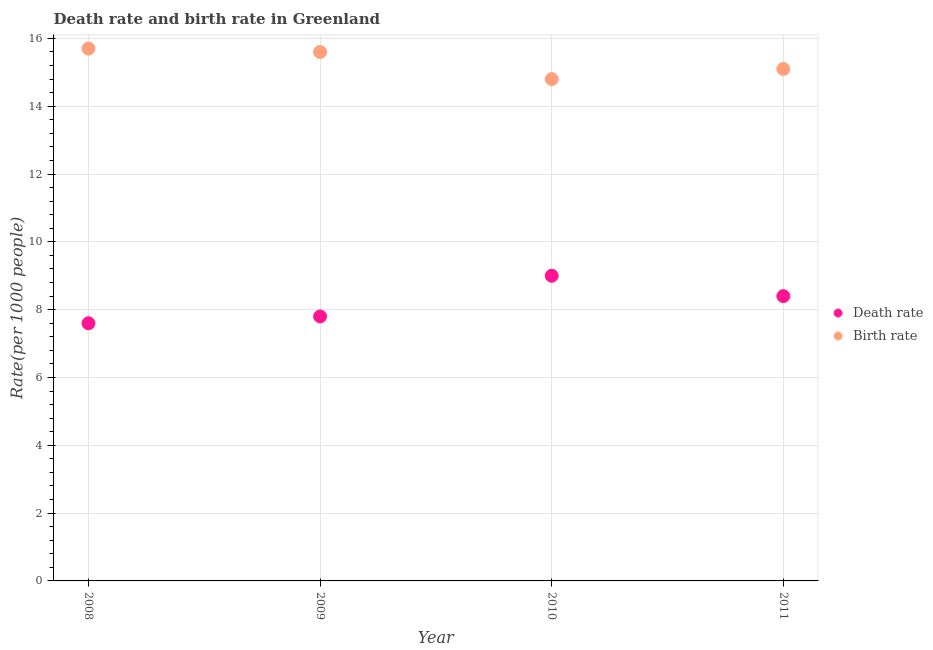How many different coloured dotlines are there?
Your response must be concise. 2. What is the death rate in 2010?
Your answer should be very brief. 9. Across all years, what is the maximum death rate?
Provide a short and direct response. 9. Across all years, what is the minimum birth rate?
Offer a terse response. 14.8. In which year was the death rate minimum?
Offer a terse response. 2008. What is the total death rate in the graph?
Offer a terse response. 32.8. What is the difference between the death rate in 2010 and that in 2011?
Ensure brevity in your answer.  0.6. What is the difference between the birth rate in 2011 and the death rate in 2009?
Provide a short and direct response. 7.3. What is the average birth rate per year?
Keep it short and to the point. 15.3. In the year 2011, what is the difference between the birth rate and death rate?
Provide a short and direct response. 6.7. In how many years, is the birth rate greater than 1.6?
Make the answer very short. 4. What is the ratio of the death rate in 2008 to that in 2009?
Provide a succinct answer. 0.97. Is the difference between the death rate in 2008 and 2009 greater than the difference between the birth rate in 2008 and 2009?
Make the answer very short. No. What is the difference between the highest and the second highest birth rate?
Your answer should be compact. 0.1. What is the difference between the highest and the lowest death rate?
Your answer should be compact. 1.4. In how many years, is the death rate greater than the average death rate taken over all years?
Your answer should be very brief. 2. Does the death rate monotonically increase over the years?
Make the answer very short. No. How many years are there in the graph?
Your answer should be compact. 4. What is the difference between two consecutive major ticks on the Y-axis?
Your answer should be compact. 2. Are the values on the major ticks of Y-axis written in scientific E-notation?
Provide a short and direct response. No. Does the graph contain any zero values?
Provide a succinct answer. No. Does the graph contain grids?
Ensure brevity in your answer.  Yes. How are the legend labels stacked?
Offer a very short reply. Vertical. What is the title of the graph?
Make the answer very short. Death rate and birth rate in Greenland. Does "constant 2005 US$" appear as one of the legend labels in the graph?
Make the answer very short. No. What is the label or title of the Y-axis?
Your response must be concise. Rate(per 1000 people). What is the Rate(per 1000 people) in Birth rate in 2008?
Provide a succinct answer. 15.7. What is the Rate(per 1000 people) of Death rate in 2009?
Keep it short and to the point. 7.8. What is the Rate(per 1000 people) of Birth rate in 2010?
Keep it short and to the point. 14.8. What is the Rate(per 1000 people) of Death rate in 2011?
Offer a very short reply. 8.4. What is the Rate(per 1000 people) of Birth rate in 2011?
Keep it short and to the point. 15.1. Across all years, what is the maximum Rate(per 1000 people) in Death rate?
Offer a very short reply. 9. Across all years, what is the minimum Rate(per 1000 people) of Death rate?
Make the answer very short. 7.6. What is the total Rate(per 1000 people) of Death rate in the graph?
Ensure brevity in your answer.  32.8. What is the total Rate(per 1000 people) in Birth rate in the graph?
Provide a short and direct response. 61.2. What is the difference between the Rate(per 1000 people) of Death rate in 2008 and that in 2010?
Give a very brief answer. -1.4. What is the difference between the Rate(per 1000 people) in Birth rate in 2008 and that in 2011?
Keep it short and to the point. 0.6. What is the difference between the Rate(per 1000 people) of Death rate in 2009 and that in 2010?
Provide a short and direct response. -1.2. What is the difference between the Rate(per 1000 people) in Birth rate in 2009 and that in 2010?
Keep it short and to the point. 0.8. What is the difference between the Rate(per 1000 people) of Death rate in 2010 and that in 2011?
Give a very brief answer. 0.6. What is the difference between the Rate(per 1000 people) of Death rate in 2008 and the Rate(per 1000 people) of Birth rate in 2011?
Offer a very short reply. -7.5. What is the difference between the Rate(per 1000 people) in Death rate in 2010 and the Rate(per 1000 people) in Birth rate in 2011?
Your answer should be compact. -6.1. What is the average Rate(per 1000 people) in Birth rate per year?
Keep it short and to the point. 15.3. In the year 2008, what is the difference between the Rate(per 1000 people) of Death rate and Rate(per 1000 people) of Birth rate?
Your answer should be very brief. -8.1. In the year 2009, what is the difference between the Rate(per 1000 people) in Death rate and Rate(per 1000 people) in Birth rate?
Provide a short and direct response. -7.8. In the year 2010, what is the difference between the Rate(per 1000 people) in Death rate and Rate(per 1000 people) in Birth rate?
Ensure brevity in your answer.  -5.8. In the year 2011, what is the difference between the Rate(per 1000 people) in Death rate and Rate(per 1000 people) in Birth rate?
Make the answer very short. -6.7. What is the ratio of the Rate(per 1000 people) of Death rate in 2008 to that in 2009?
Ensure brevity in your answer.  0.97. What is the ratio of the Rate(per 1000 people) of Birth rate in 2008 to that in 2009?
Offer a terse response. 1.01. What is the ratio of the Rate(per 1000 people) in Death rate in 2008 to that in 2010?
Offer a very short reply. 0.84. What is the ratio of the Rate(per 1000 people) in Birth rate in 2008 to that in 2010?
Provide a succinct answer. 1.06. What is the ratio of the Rate(per 1000 people) of Death rate in 2008 to that in 2011?
Offer a very short reply. 0.9. What is the ratio of the Rate(per 1000 people) in Birth rate in 2008 to that in 2011?
Your answer should be very brief. 1.04. What is the ratio of the Rate(per 1000 people) of Death rate in 2009 to that in 2010?
Ensure brevity in your answer.  0.87. What is the ratio of the Rate(per 1000 people) in Birth rate in 2009 to that in 2010?
Offer a very short reply. 1.05. What is the ratio of the Rate(per 1000 people) of Death rate in 2009 to that in 2011?
Your response must be concise. 0.93. What is the ratio of the Rate(per 1000 people) of Birth rate in 2009 to that in 2011?
Your answer should be compact. 1.03. What is the ratio of the Rate(per 1000 people) in Death rate in 2010 to that in 2011?
Your answer should be compact. 1.07. What is the ratio of the Rate(per 1000 people) of Birth rate in 2010 to that in 2011?
Provide a short and direct response. 0.98. What is the difference between the highest and the second highest Rate(per 1000 people) of Birth rate?
Make the answer very short. 0.1. What is the difference between the highest and the lowest Rate(per 1000 people) in Death rate?
Offer a very short reply. 1.4. What is the difference between the highest and the lowest Rate(per 1000 people) of Birth rate?
Make the answer very short. 0.9. 